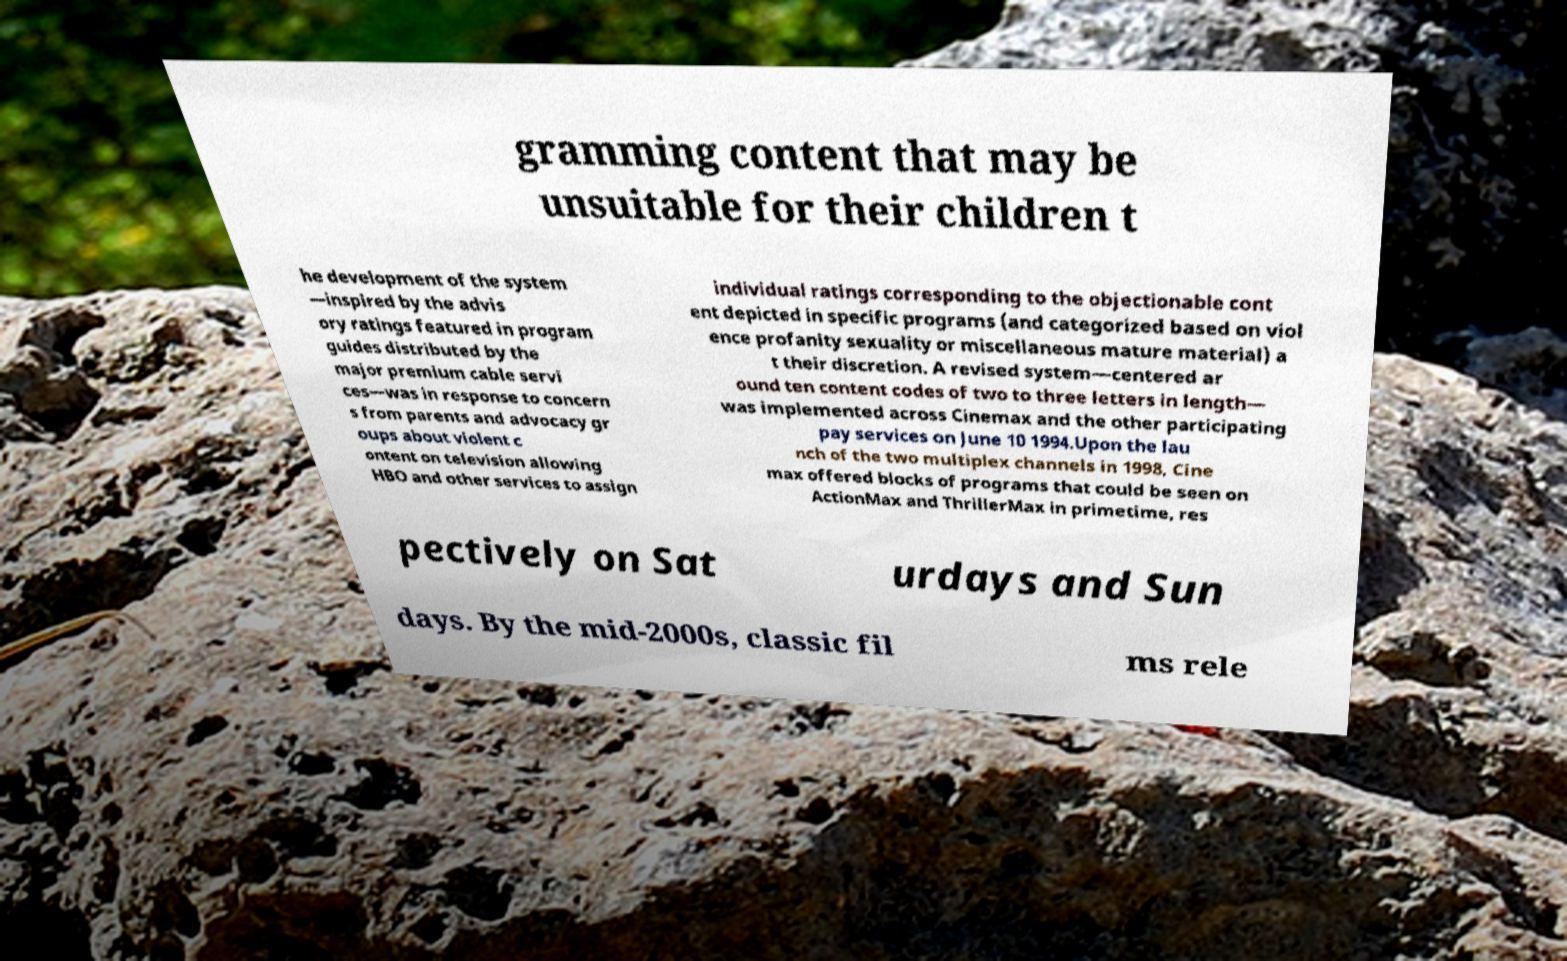Please identify and transcribe the text found in this image. gramming content that may be unsuitable for their children t he development of the system —inspired by the advis ory ratings featured in program guides distributed by the major premium cable servi ces—was in response to concern s from parents and advocacy gr oups about violent c ontent on television allowing HBO and other services to assign individual ratings corresponding to the objectionable cont ent depicted in specific programs (and categorized based on viol ence profanity sexuality or miscellaneous mature material) a t their discretion. A revised system—centered ar ound ten content codes of two to three letters in length— was implemented across Cinemax and the other participating pay services on June 10 1994.Upon the lau nch of the two multiplex channels in 1998, Cine max offered blocks of programs that could be seen on ActionMax and ThrillerMax in primetime, res pectively on Sat urdays and Sun days. By the mid-2000s, classic fil ms rele 